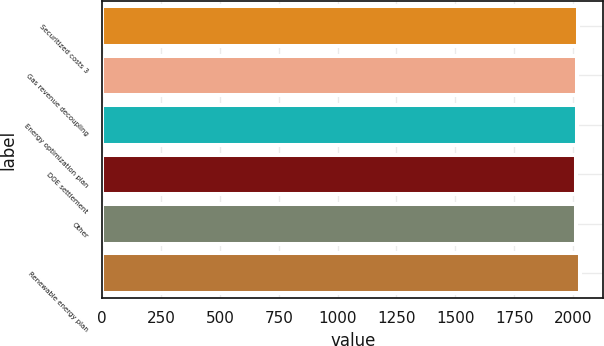<chart> <loc_0><loc_0><loc_500><loc_500><bar_chart><fcel>Securitized costs 3<fcel>Gas revenue decoupling<fcel>Energy optimization plan<fcel>DOE settlement<fcel>Other<fcel>Renewable energy plan<nl><fcel>2020.5<fcel>2016<fcel>2019<fcel>2013<fcel>2014.5<fcel>2028<nl></chart> 